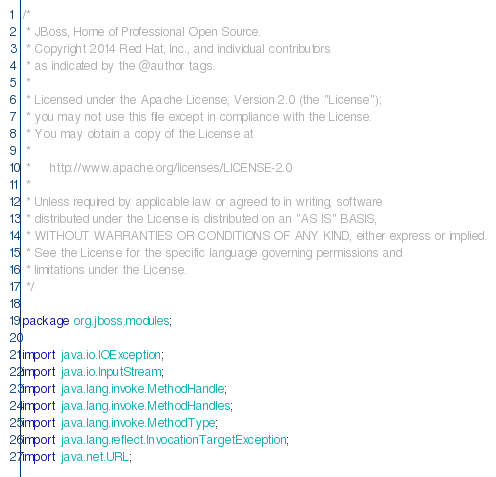<code> <loc_0><loc_0><loc_500><loc_500><_Java_>/*
 * JBoss, Home of Professional Open Source.
 * Copyright 2014 Red Hat, Inc., and individual contributors
 * as indicated by the @author tags.
 *
 * Licensed under the Apache License, Version 2.0 (the "License");
 * you may not use this file except in compliance with the License.
 * You may obtain a copy of the License at
 *
 *     http://www.apache.org/licenses/LICENSE-2.0
 *
 * Unless required by applicable law or agreed to in writing, software
 * distributed under the License is distributed on an "AS IS" BASIS,
 * WITHOUT WARRANTIES OR CONDITIONS OF ANY KIND, either express or implied.
 * See the License for the specific language governing permissions and
 * limitations under the License.
 */

package org.jboss.modules;

import java.io.IOException;
import java.io.InputStream;
import java.lang.invoke.MethodHandle;
import java.lang.invoke.MethodHandles;
import java.lang.invoke.MethodType;
import java.lang.reflect.InvocationTargetException;
import java.net.URL;</code> 